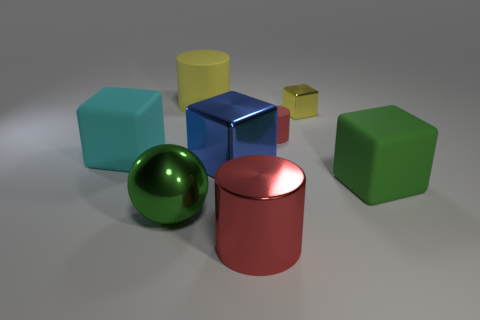There is a ball; is its size the same as the rubber block right of the big yellow rubber cylinder?
Keep it short and to the point. Yes. Is there a big cyan sphere that has the same material as the large red thing?
Ensure brevity in your answer.  No. How many cylinders are yellow rubber things or red matte things?
Provide a short and direct response. 2. Is there a yellow object in front of the cyan rubber object to the left of the large red metal thing?
Provide a short and direct response. No. Are there fewer green metal spheres than large blocks?
Offer a very short reply. Yes. How many green rubber things have the same shape as the small red matte object?
Your response must be concise. 0. How many gray objects are big matte cubes or big shiny cylinders?
Make the answer very short. 0. There is a metallic block behind the rubber cylinder to the right of the large metal cylinder; what is its size?
Ensure brevity in your answer.  Small. What is the material of the big green object that is the same shape as the tiny metal thing?
Ensure brevity in your answer.  Rubber. How many green shiny balls are the same size as the yellow block?
Give a very brief answer. 0. 